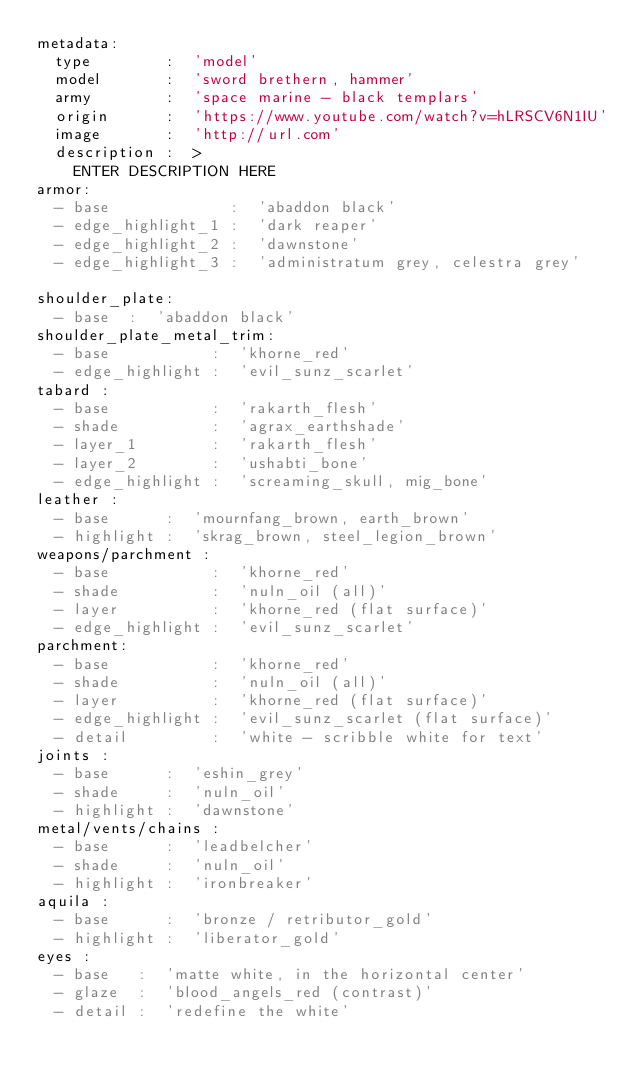Convert code to text. <code><loc_0><loc_0><loc_500><loc_500><_YAML_>metadata:
  type        :  'model'
  model       :  'sword brethern, hammer'
  army        :  'space marine - black templars'
  origin      :  'https://www.youtube.com/watch?v=hLRSCV6N1IU'
  image       :  'http://url.com'
  description :  >
    ENTER DESCRIPTION HERE
armor:
  - base             :  'abaddon black'
  - edge_highlight_1 :  'dark reaper'
  - edge_highlight_2 :  'dawnstone'
  - edge_highlight_3 :  'administratum grey, celestra grey'

shoulder_plate:
  - base  :  'abaddon black'
shoulder_plate_metal_trim:
  - base           :  'khorne_red'
  - edge_highlight :  'evil_sunz_scarlet'
tabard :
  - base           :  'rakarth_flesh'
  - shade          :  'agrax_earthshade'
  - layer_1        :  'rakarth_flesh'
  - layer_2        :  'ushabti_bone'
  - edge_highlight :  'screaming_skull, mig_bone'
leather :
  - base      :  'mournfang_brown, earth_brown'
  - highlight :  'skrag_brown, steel_legion_brown'
weapons/parchment :
  - base           :  'khorne_red'
  - shade          :  'nuln_oil (all)'
  - layer          :  'khorne_red (flat surface)'
  - edge_highlight :  'evil_sunz_scarlet'
parchment:
  - base           :  'khorne_red'
  - shade          :  'nuln_oil (all)'
  - layer          :  'khorne_red (flat surface)'
  - edge_highlight :  'evil_sunz_scarlet (flat surface)'
  - detail         :  'white - scribble white for text'
joints :
  - base      :  'eshin_grey'
  - shade     :  'nuln_oil'
  - highlight :  'dawnstone'
metal/vents/chains :
  - base      :  'leadbelcher'
  - shade     :  'nuln_oil'
  - highlight :  'ironbreaker'
aquila :
  - base      :  'bronze / retributor_gold'
  - highlight :  'liberator_gold'
eyes :
  - base   :  'matte white, in the horizontal center'
  - glaze  :  'blood_angels_red (contrast)'
  - detail :  'redefine the white'
</code> 